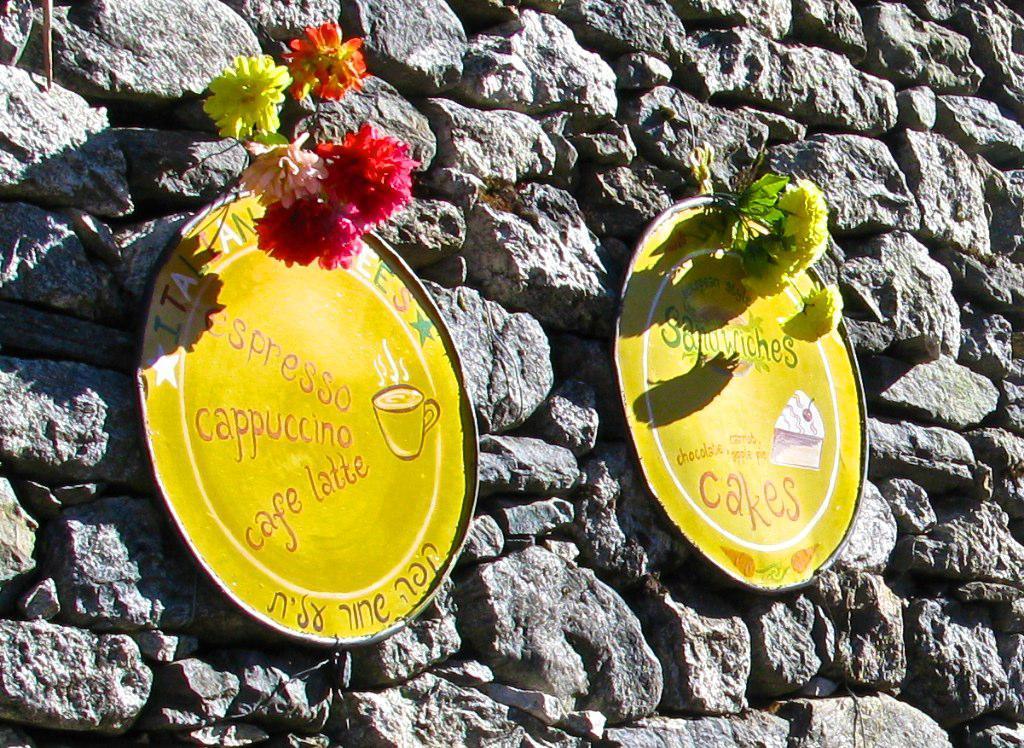How would you summarize this image in a sentence or two? In this picture I can observe two yellow color boards on the stone wall. I can observe flowers which are in yellow, red, pink and orange colors in this picture. 